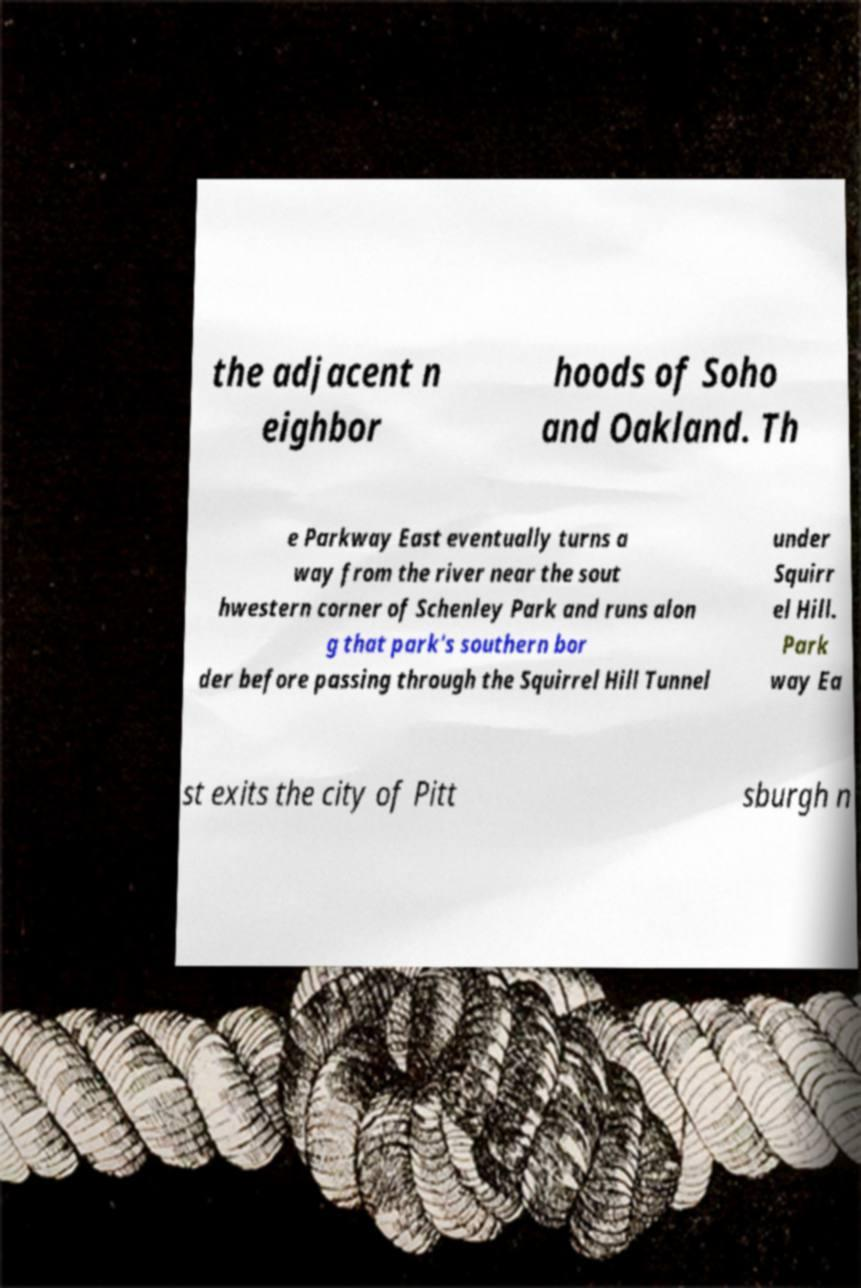Can you accurately transcribe the text from the provided image for me? the adjacent n eighbor hoods of Soho and Oakland. Th e Parkway East eventually turns a way from the river near the sout hwestern corner of Schenley Park and runs alon g that park's southern bor der before passing through the Squirrel Hill Tunnel under Squirr el Hill. Park way Ea st exits the city of Pitt sburgh n 